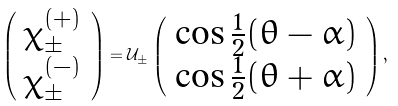<formula> <loc_0><loc_0><loc_500><loc_500>\left ( \begin{array} { c } \chi _ { \pm } ^ { ( + ) } \\ \chi _ { \pm } ^ { ( - ) } \end{array} \right ) = { \mathcal { U } } _ { \pm } \left ( \begin{array} { c } \cos \frac { 1 } { 2 } ( \theta - \alpha ) \\ \cos \frac { 1 } { 2 } ( \theta + \alpha ) \end{array} \right ) ,</formula> 